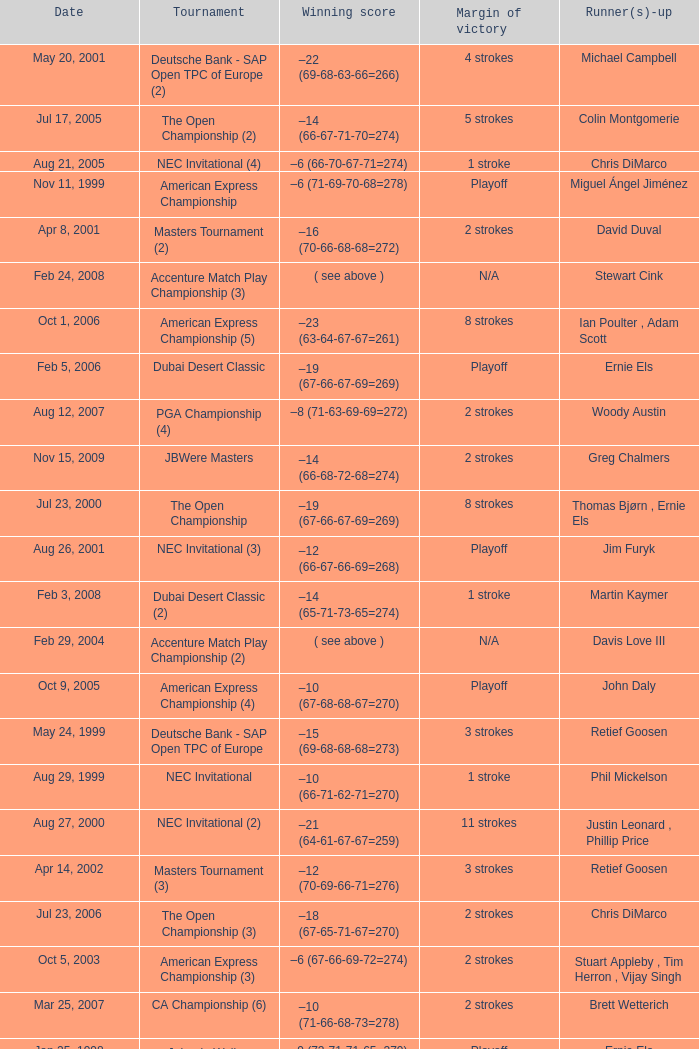Who is Runner(s)-up that has a Date of may 24, 1999? Retief Goosen. 